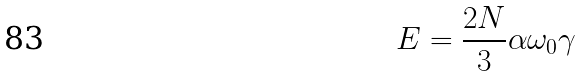Convert formula to latex. <formula><loc_0><loc_0><loc_500><loc_500>E = \frac { 2 N } { 3 } \alpha \omega _ { 0 } \gamma</formula> 